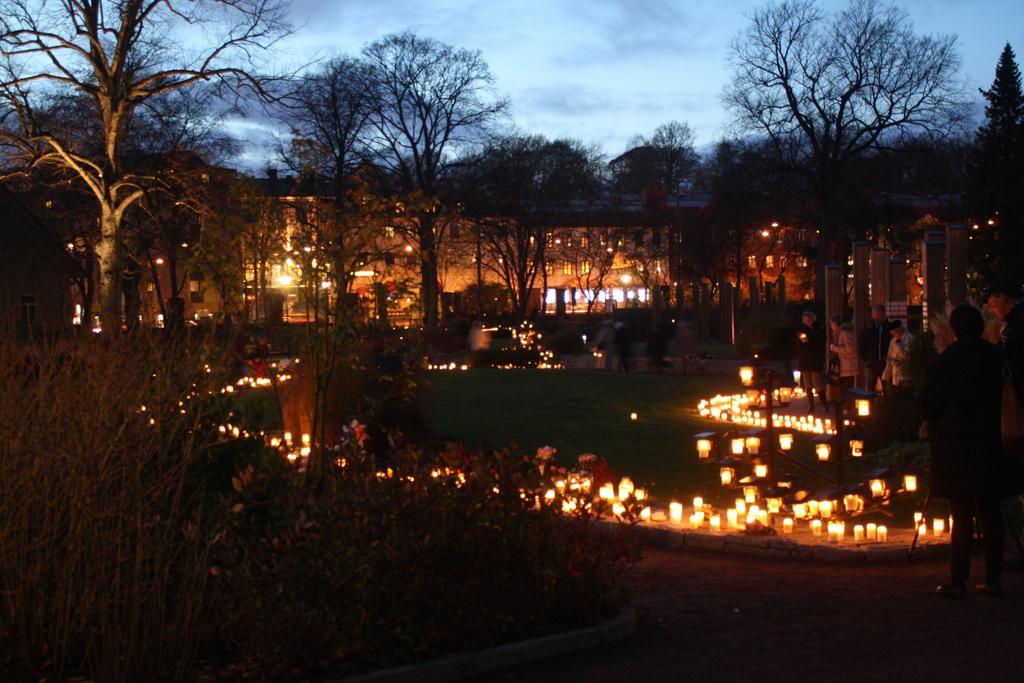How would you summarize this image in a sentence or two? As we can see in the image there are lights, buildings, trees, sky and clouds. The image is little dark. 